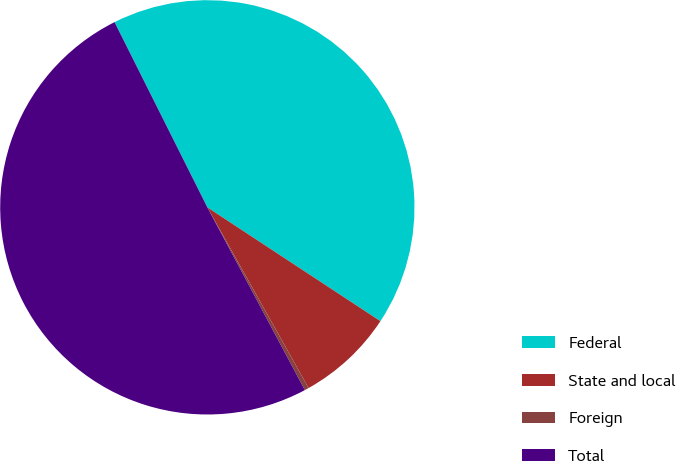Convert chart. <chart><loc_0><loc_0><loc_500><loc_500><pie_chart><fcel>Federal<fcel>State and local<fcel>Foreign<fcel>Total<nl><fcel>41.65%<fcel>7.61%<fcel>0.33%<fcel>50.41%<nl></chart> 